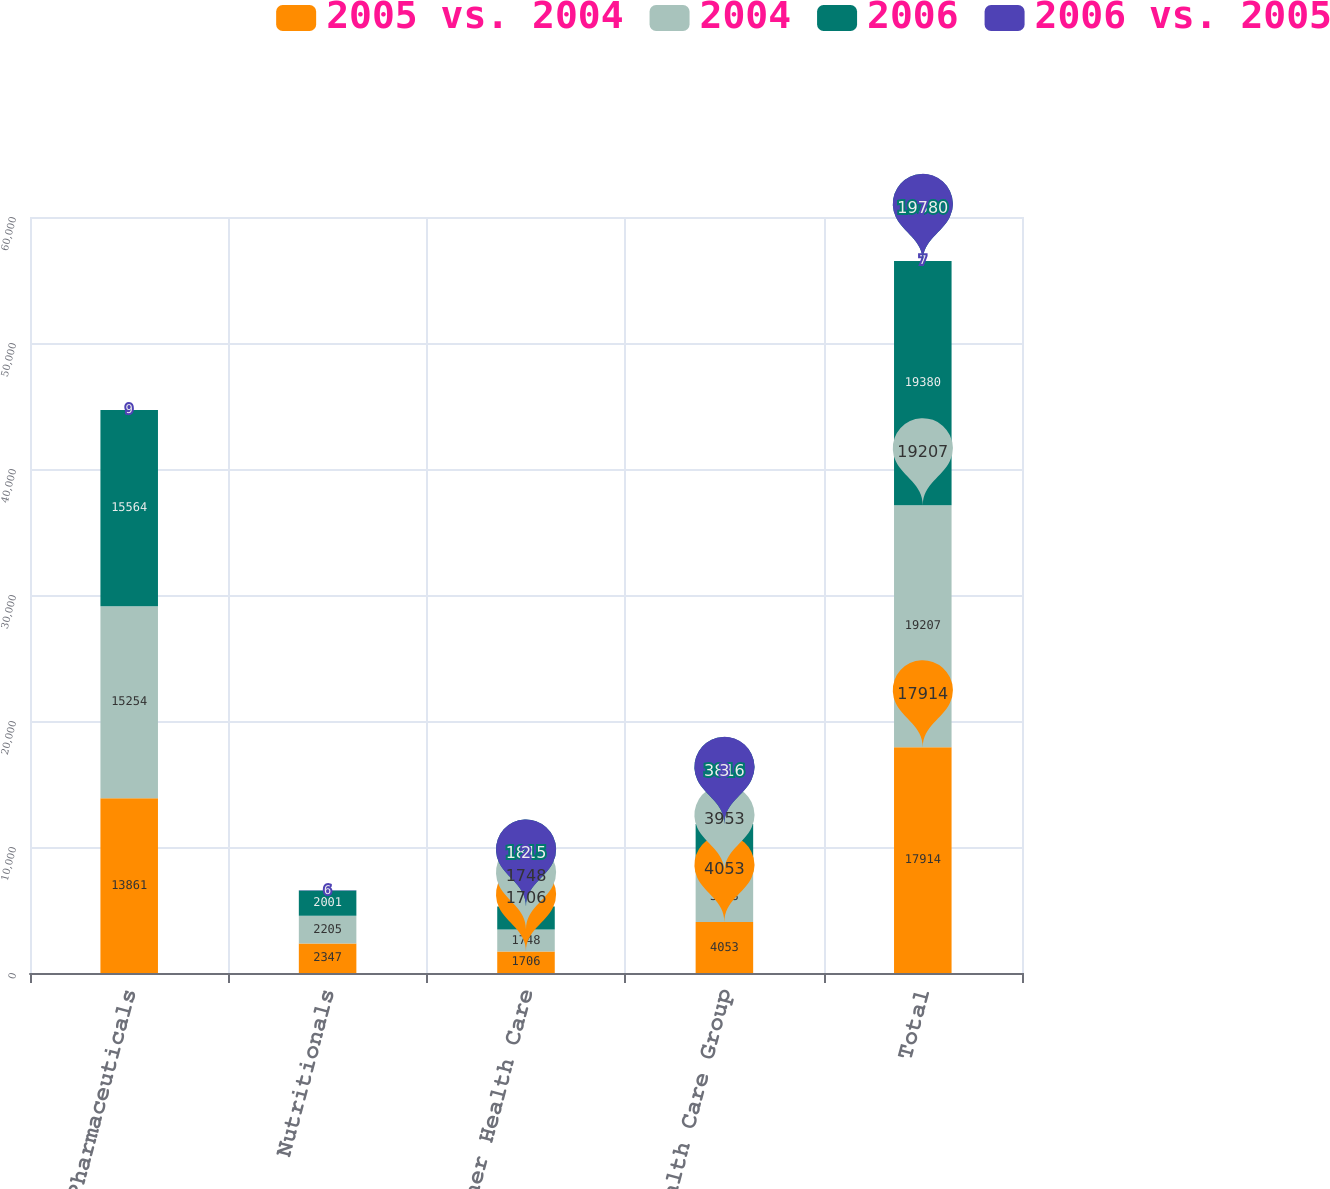Convert chart. <chart><loc_0><loc_0><loc_500><loc_500><stacked_bar_chart><ecel><fcel>Pharmaceuticals<fcel>Nutritionals<fcel>Other Health Care<fcel>Health Care Group<fcel>Total<nl><fcel>2005 vs. 2004<fcel>13861<fcel>2347<fcel>1706<fcel>4053<fcel>17914<nl><fcel>2004<fcel>15254<fcel>2205<fcel>1748<fcel>3953<fcel>19207<nl><fcel>2006<fcel>15564<fcel>2001<fcel>1815<fcel>3816<fcel>19380<nl><fcel>2006 vs. 2005<fcel>9<fcel>6<fcel>2<fcel>3<fcel>7<nl></chart> 